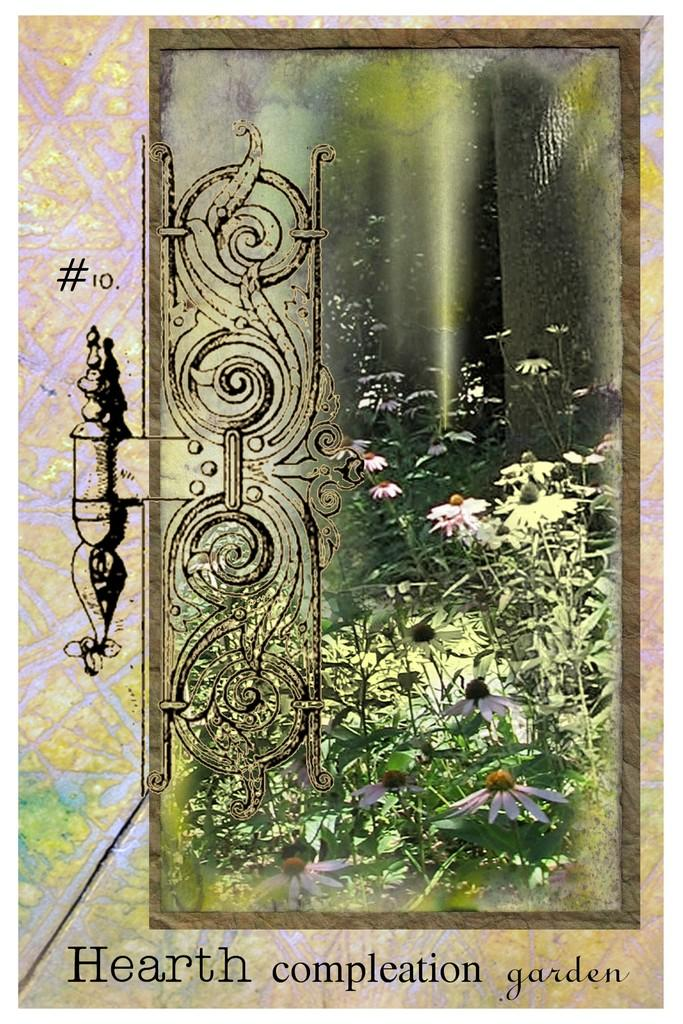What is the main subject of the image? There is a painting in the image. What elements are included in the painting? The painting contains a door and plants. Is there any text present in the image? Yes, there is some text at the bottom of the image. How many spiders can be seen crawling on the door in the painting? There are no spiders visible in the painting; it only contains a door and plants. What type of drink is being served in the painting? There is no drink present in the painting; it only contains a door and plants. 